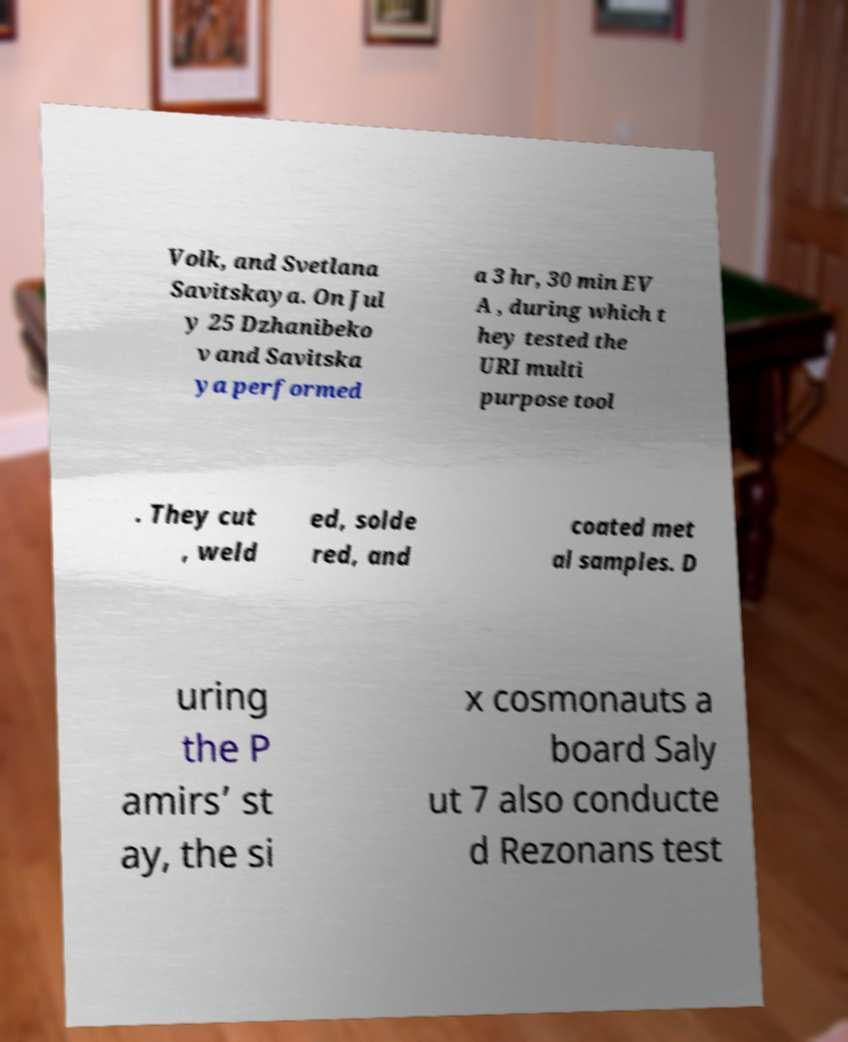For documentation purposes, I need the text within this image transcribed. Could you provide that? Volk, and Svetlana Savitskaya. On Jul y 25 Dzhanibeko v and Savitska ya performed a 3 hr, 30 min EV A , during which t hey tested the URI multi purpose tool . They cut , weld ed, solde red, and coated met al samples. D uring the P amirs’ st ay, the si x cosmonauts a board Saly ut 7 also conducte d Rezonans test 